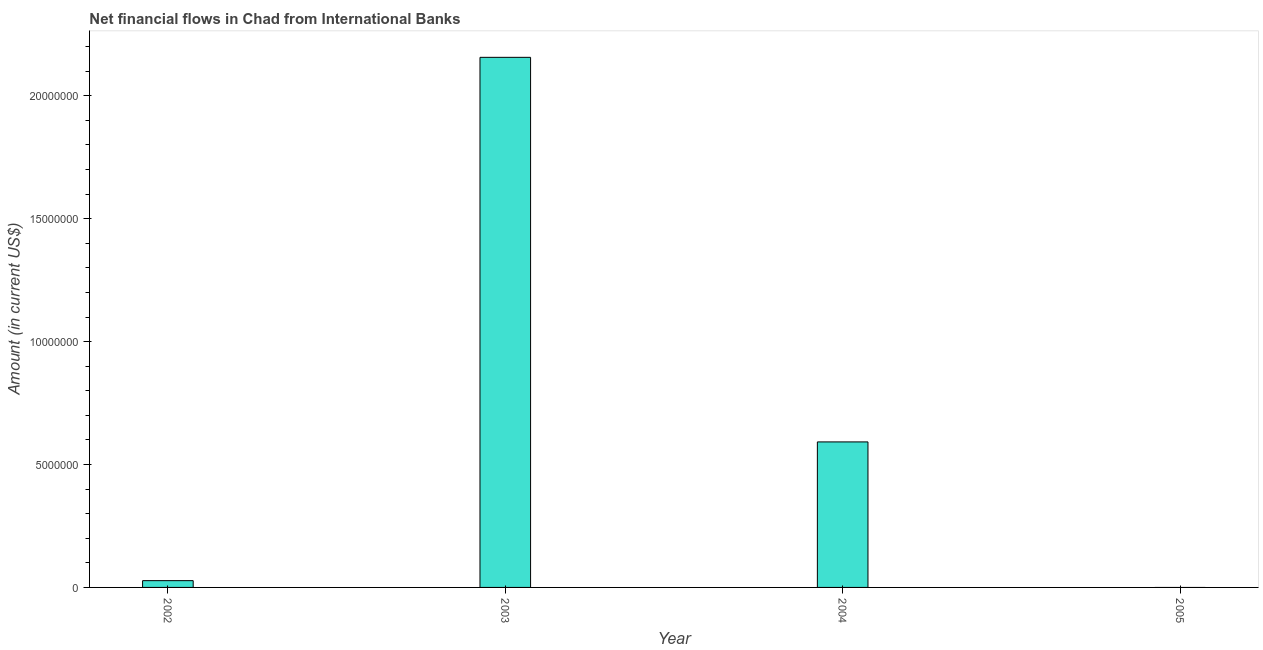Does the graph contain grids?
Your answer should be compact. No. What is the title of the graph?
Provide a succinct answer. Net financial flows in Chad from International Banks. What is the net financial flows from ibrd in 2002?
Ensure brevity in your answer.  2.76e+05. Across all years, what is the maximum net financial flows from ibrd?
Offer a very short reply. 2.16e+07. What is the sum of the net financial flows from ibrd?
Your answer should be very brief. 2.78e+07. What is the difference between the net financial flows from ibrd in 2002 and 2004?
Your answer should be compact. -5.64e+06. What is the average net financial flows from ibrd per year?
Provide a short and direct response. 6.94e+06. What is the median net financial flows from ibrd?
Give a very brief answer. 3.10e+06. In how many years, is the net financial flows from ibrd greater than 21000000 US$?
Give a very brief answer. 1. What is the ratio of the net financial flows from ibrd in 2003 to that in 2004?
Offer a very short reply. 3.64. What is the difference between the highest and the second highest net financial flows from ibrd?
Provide a succinct answer. 1.56e+07. Is the sum of the net financial flows from ibrd in 2002 and 2004 greater than the maximum net financial flows from ibrd across all years?
Offer a very short reply. No. What is the difference between the highest and the lowest net financial flows from ibrd?
Offer a very short reply. 2.16e+07. In how many years, is the net financial flows from ibrd greater than the average net financial flows from ibrd taken over all years?
Offer a very short reply. 1. How many years are there in the graph?
Give a very brief answer. 4. Are the values on the major ticks of Y-axis written in scientific E-notation?
Your response must be concise. No. What is the Amount (in current US$) in 2002?
Provide a succinct answer. 2.76e+05. What is the Amount (in current US$) in 2003?
Keep it short and to the point. 2.16e+07. What is the Amount (in current US$) in 2004?
Make the answer very short. 5.92e+06. What is the Amount (in current US$) of 2005?
Offer a very short reply. 0. What is the difference between the Amount (in current US$) in 2002 and 2003?
Ensure brevity in your answer.  -2.13e+07. What is the difference between the Amount (in current US$) in 2002 and 2004?
Your answer should be compact. -5.64e+06. What is the difference between the Amount (in current US$) in 2003 and 2004?
Offer a very short reply. 1.56e+07. What is the ratio of the Amount (in current US$) in 2002 to that in 2003?
Your answer should be very brief. 0.01. What is the ratio of the Amount (in current US$) in 2002 to that in 2004?
Give a very brief answer. 0.05. What is the ratio of the Amount (in current US$) in 2003 to that in 2004?
Provide a short and direct response. 3.64. 